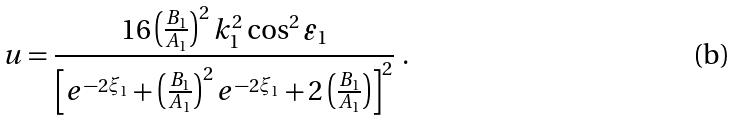<formula> <loc_0><loc_0><loc_500><loc_500>u = \frac { 1 6 \left ( \frac { B _ { 1 } } { A _ { 1 } } \right ) ^ { 2 } k _ { 1 } ^ { 2 } \cos ^ { 2 } \varepsilon _ { 1 } } { \left [ e ^ { - 2 \xi _ { 1 } } + \left ( \frac { B _ { 1 } } { A _ { 1 } } \right ) ^ { 2 } e ^ { - 2 \xi _ { 1 } } + 2 \left ( \frac { B _ { 1 } } { A _ { 1 } } \right ) \right ] ^ { 2 } } \ .</formula> 